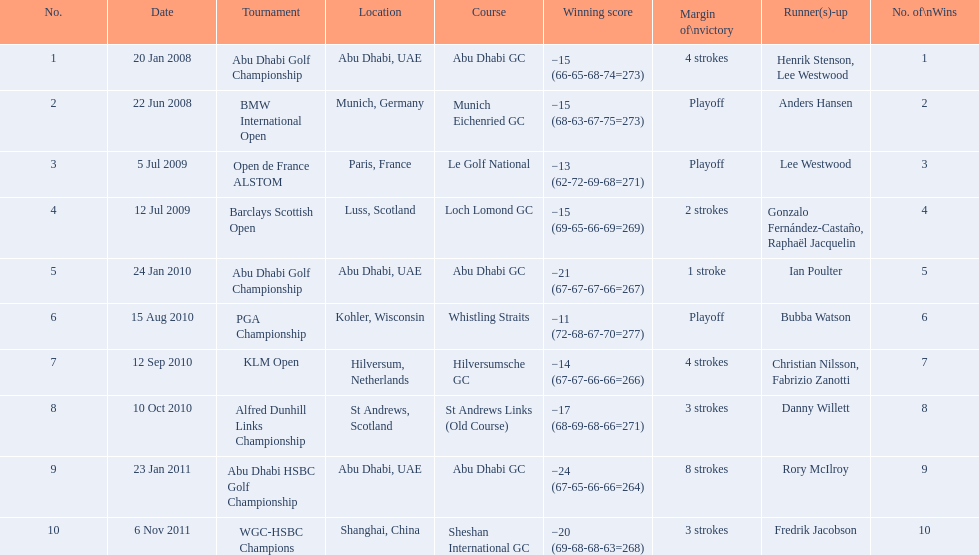What were all the different tournaments played by martin kaymer Abu Dhabi Golf Championship, BMW International Open, Open de France ALSTOM, Barclays Scottish Open, Abu Dhabi Golf Championship, PGA Championship, KLM Open, Alfred Dunhill Links Championship, Abu Dhabi HSBC Golf Championship, WGC-HSBC Champions. Who was the runner-up for the pga championship? Bubba Watson. 